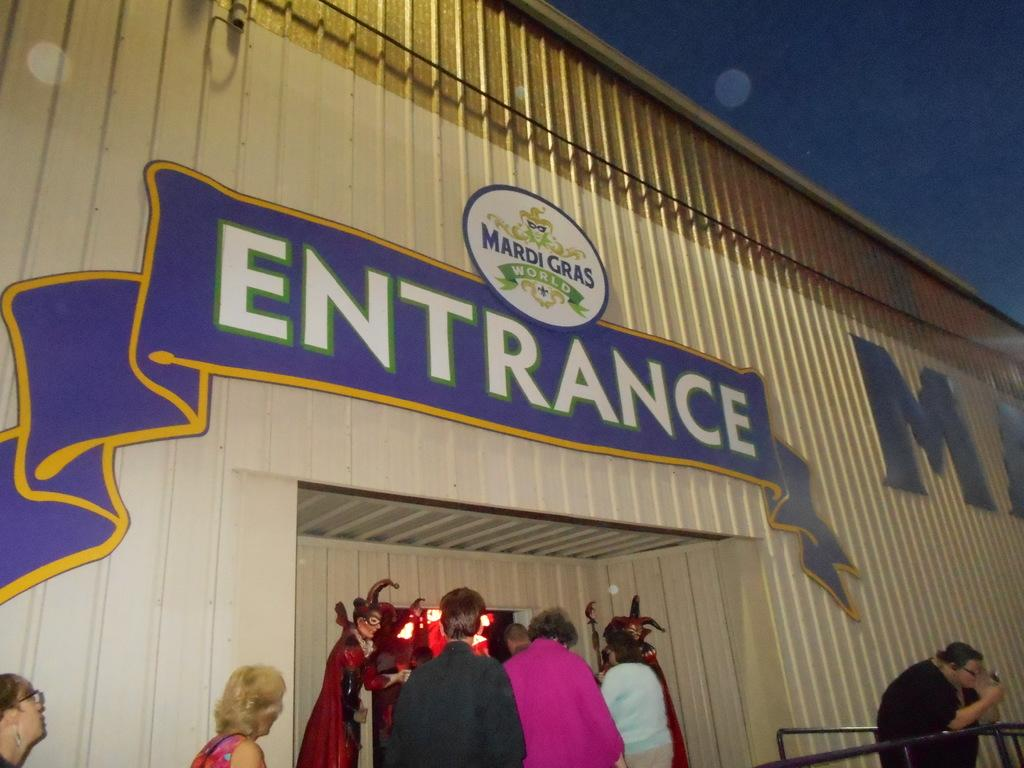<image>
Create a compact narrative representing the image presented. People are walking in the entrance of Mardi Gras World building. 